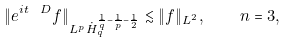Convert formula to latex. <formula><loc_0><loc_0><loc_500><loc_500>\| e ^ { i t \ D } f \| _ { L ^ { p } \dot { H } _ { q } ^ { \frac { 1 } { q } - \frac { 1 } { p } - \frac { 1 } { 2 } } } \lesssim \| f \| _ { L ^ { 2 } } , \quad n = 3 ,</formula> 